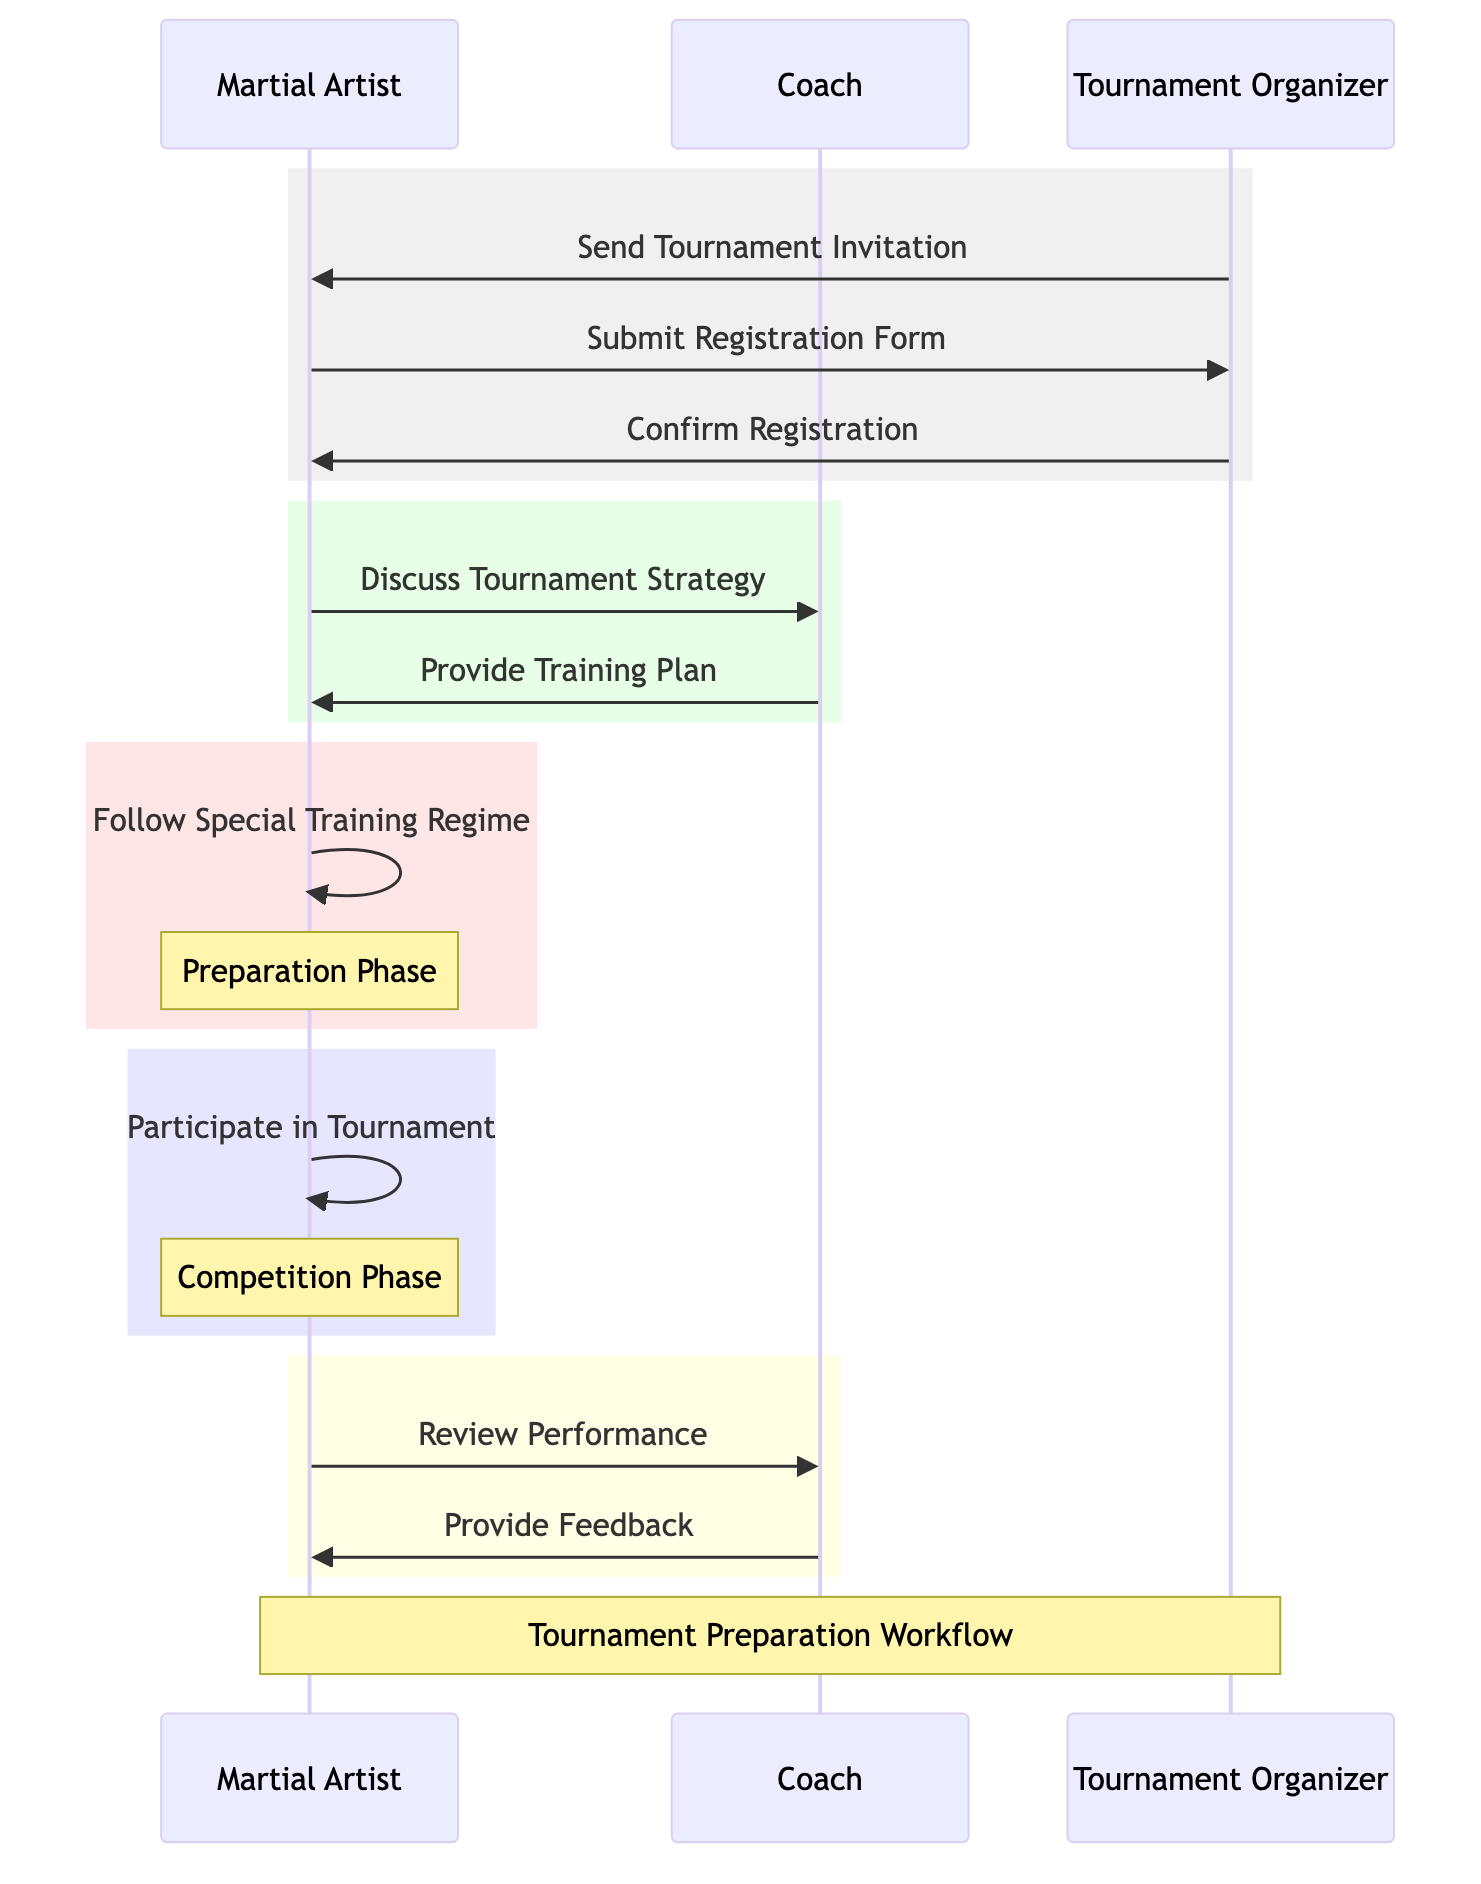What is the first message in the sequence? The first message in the sequence is from the Tournament Organizer to the Martial Artist, which is the "Send Tournament Invitation".
Answer: Send Tournament Invitation How many actors are present in the diagram? There are three actors in the diagram: Martial Artist, Coach, and Tournament Organizer.
Answer: 3 What does the Martial Artist do immediately after submitting the registration form? After the Martial Artist submits the registration form, they receive a confirmation message from the Tournament Organizer.
Answer: Confirm Registration Which participant provides the training plan? The training plan is provided by the Coach to the Martial Artist after discussing the tournament strategy.
Answer: Coach What is the significance of the message "Review Performance"? The message "Review Performance" indicates that the Martial Artist seeks feedback from the Coach after participating in the tournament, marking the post-competition review step.
Answer: Post-competition review How many messages are exchanged between the Martial Artist and the Tournament Organizer? The diagram shows a total of three messages exchanged between the Martial Artist and the Tournament Organizer during the registration process.
Answer: 3 Which phase includes the message "Follow Special Training Regime"? The message "Follow Special Training Regime" occurs during the Preparation Phase, indicating the Martial Artist is training before the tournament.
Answer: Preparation Phase What is the last action taken by the Coach in the sequence? The last action taken by the Coach in the sequence is to provide feedback to the Martial Artist after reviewing their performance.
Answer: Provide Feedback Which phase does "Participate in Tournament" belong to? "Participate in Tournament" belongs to the Competition Phase, where the Martial Artist competes in the tournament itself.
Answer: Competition Phase 